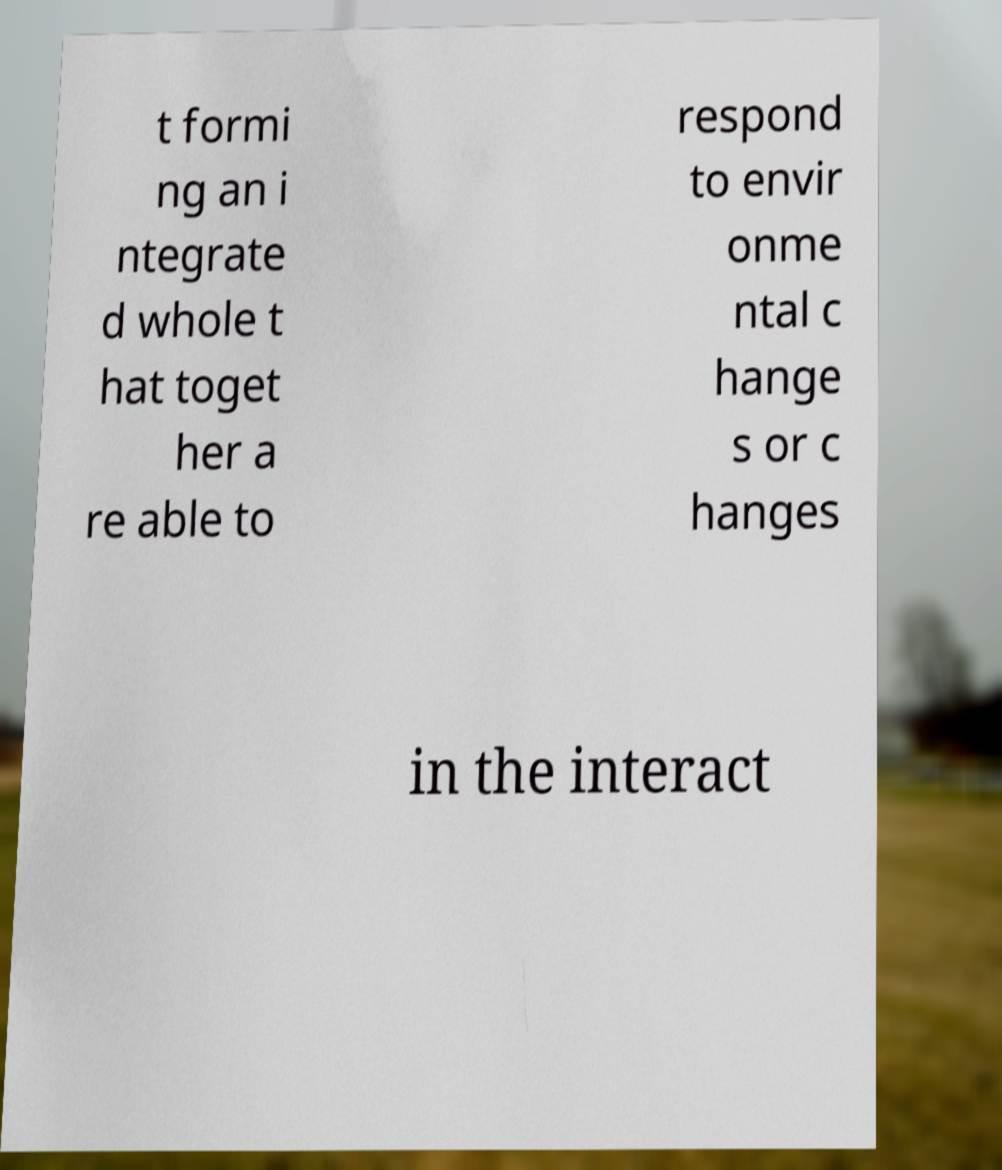Could you assist in decoding the text presented in this image and type it out clearly? t formi ng an i ntegrate d whole t hat toget her a re able to respond to envir onme ntal c hange s or c hanges in the interact 